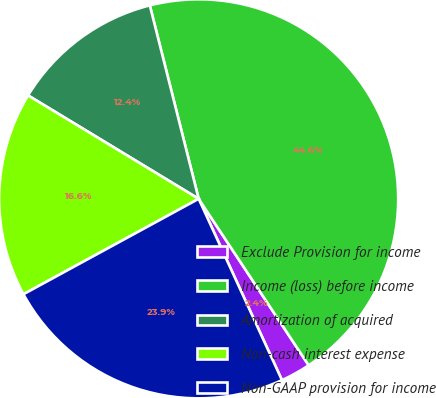<chart> <loc_0><loc_0><loc_500><loc_500><pie_chart><fcel>Exclude Provision for income<fcel>Income (loss) before income<fcel>Amortization of acquired<fcel>Non-cash interest expense<fcel>Non-GAAP provision for income<nl><fcel>2.44%<fcel>44.65%<fcel>12.39%<fcel>16.61%<fcel>23.92%<nl></chart> 